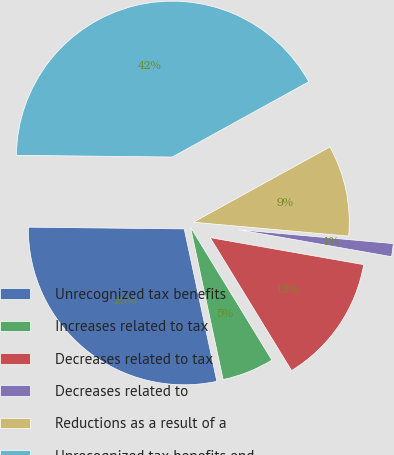Convert chart. <chart><loc_0><loc_0><loc_500><loc_500><pie_chart><fcel>Unrecognized tax benefits<fcel>Increases related to tax<fcel>Decreases related to tax<fcel>Decreases related to<fcel>Reductions as a result of a<fcel>Unrecognized tax benefits end<nl><fcel>28.53%<fcel>5.39%<fcel>13.48%<fcel>1.35%<fcel>9.44%<fcel>41.8%<nl></chart> 